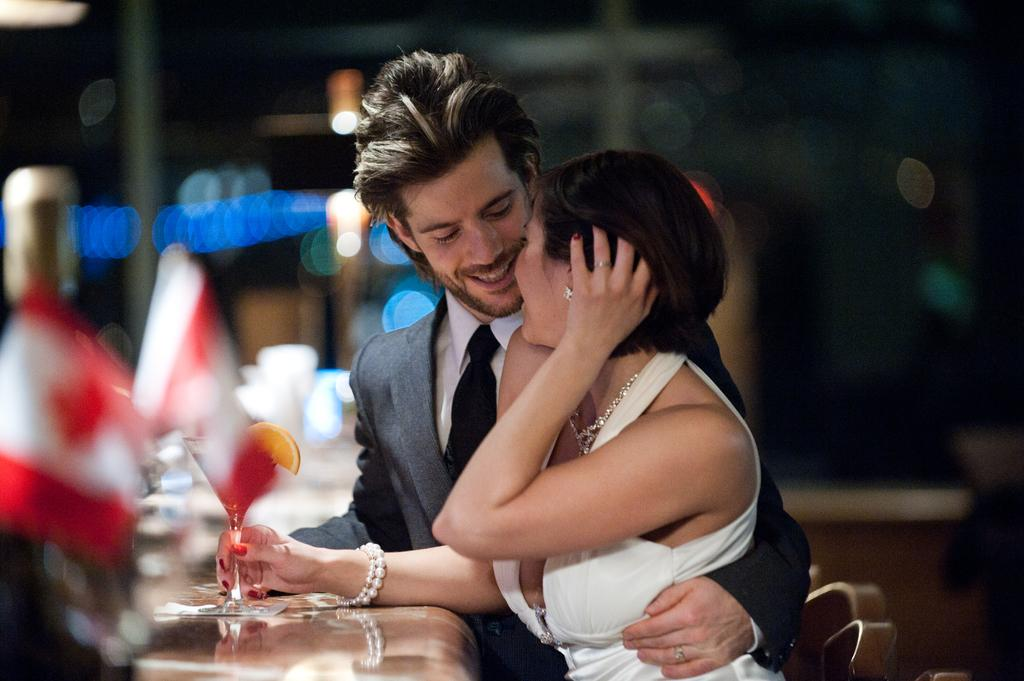How many people are in the image? There is a man and a woman in the image. What are the man and woman doing in the image? The man and woman are standing near a table. What is the woman holding in the image? The woman is holding a glass with juice, and there is a lemon on the glass. What can be said about the background of the image? The background of the image is blurry. What type of seed is the man planting in the image? There is no seed or planting activity present in the image; it features a man and a woman standing near a table. 